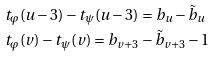Convert formula to latex. <formula><loc_0><loc_0><loc_500><loc_500>& t _ { \varphi } ( u - 3 ) - t _ { \psi } ( u - 3 ) = b _ { u } - \tilde { b } _ { u } \\ & t _ { \varphi } ( v ) - t _ { \psi } ( v ) = b _ { v + 3 } - \tilde { b } _ { v + 3 } - 1</formula> 